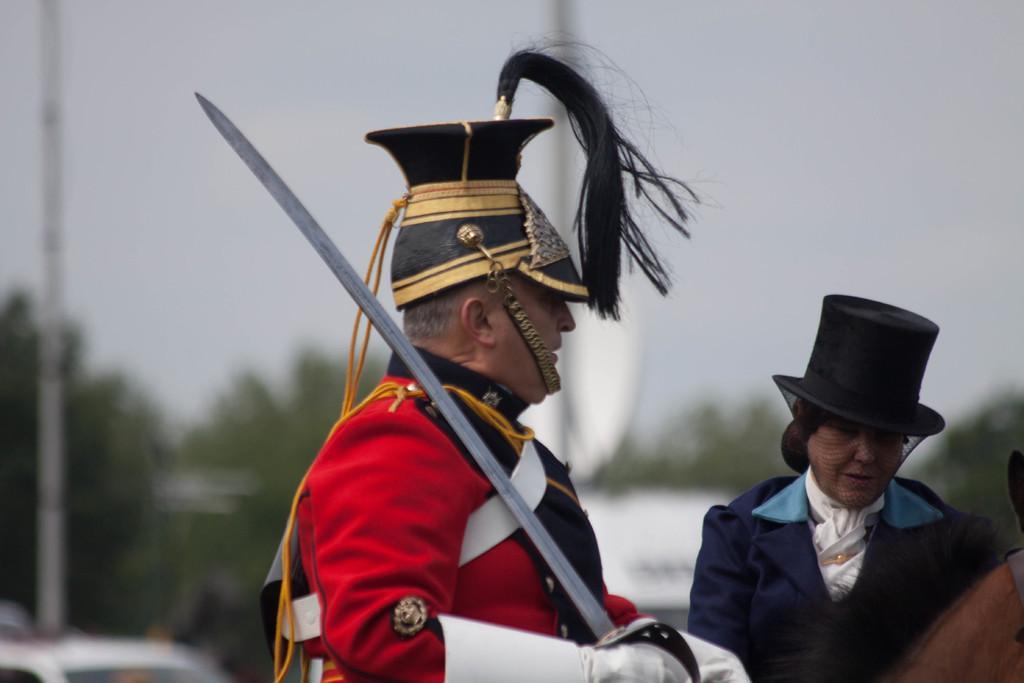Please provide a concise description of this image. In this image there are two persons, an animal, trees, and in the background there is sky. 